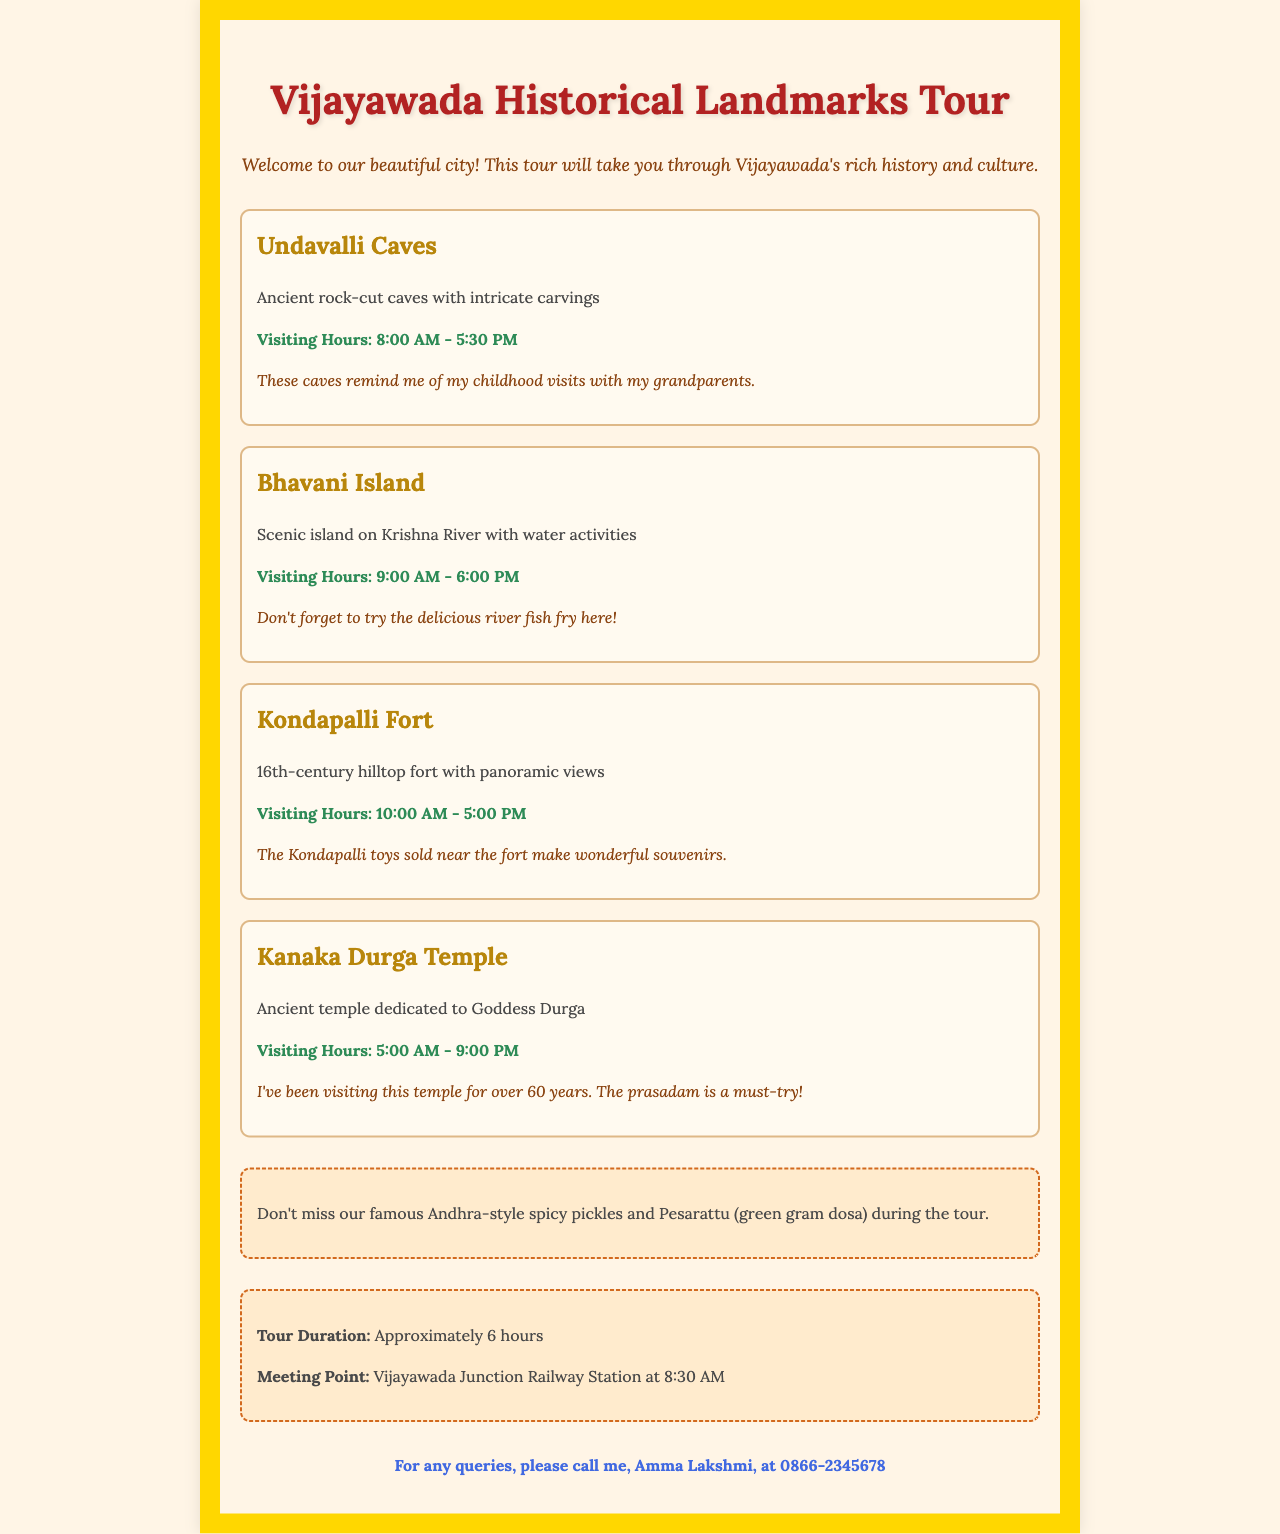What are the Undavalli Caves? The Undavalli Caves are ancient rock-cut caves with intricate carvings.
Answer: Ancient rock-cut caves with intricate carvings What are the visiting hours for Kanaka Durga Temple? The visiting hours for Kanaka Durga Temple are specified in the document.
Answer: 5:00 AM - 9:00 PM What is the meeting point for the tour? The meeting point for the tour is mentioned in the tour information section.
Answer: Vijayawada Junction Railway Station at 8:30 AM How long is the tour duration? The tour duration is stated clearly in the document.
Answer: Approximately 6 hours What local food is recommended during the tour? The document provides details about local food not to miss during the tour.
Answer: Andhra-style spicy pickles and Pesarattu What can you do at Bhavani Island? Bhavani Island offers specified activities mentioned in the description.
Answer: Water activities What unique item can you buy near Kondapalli Fort? The document notes shopping advice when visiting Kondapalli Fort.
Answer: Kondapalli toys How long have you been visiting Kanaka Durga Temple? The document includes a personal note about the duration of visits to the temple.
Answer: Over 60 years 